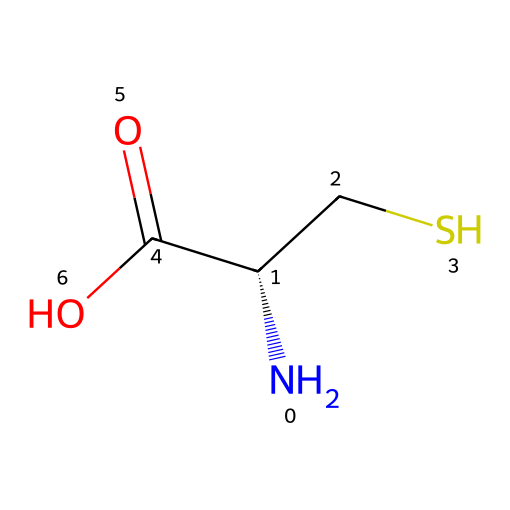How many carbon atoms are in cysteine? The SMILES representation shows two carbon atoms (C) in the main chain and one carbon in the thiol group (CS), resulting in a total of three carbon atoms.
Answer: three What is the functional group of cysteine that contains sulfur? The symbol "S" in the SMILES indicates the presence of a thiol functional group (-SH), which is characteristic of cysteine.
Answer: thiol How many nitrogen atoms are present in cysteine? The SMILES representation includes one nitrogen atom (N), which is part of the amino group of the amino acid structure.
Answer: one What type of amino acid is cysteine classified as based on its side chain? The presence of the thiol group (CS) in the side chain makes cysteine a polar amino acid.
Answer: polar What is the total number of bonds in cysteine's primary structure as indicated in the SMILES? The structure consists of a carbon backbone with multiple single bonds and one double bond (C(=O)), totaling around six bonds when accounting for all connections.
Answer: six What element in cysteine contributes to its antioxidant properties? The sulfur atom (S) in the thiol group is crucial for cysteine's antioxidant activity, as it can donate electrons.
Answer: sulfur What is the stereochemical configuration of cysteine as indicated by the SMILES notation? The "C@@H" indicates that cysteine has a chiral center, specifically a specific stereochemistry, meaning it exists in an L-form.
Answer: L-form 